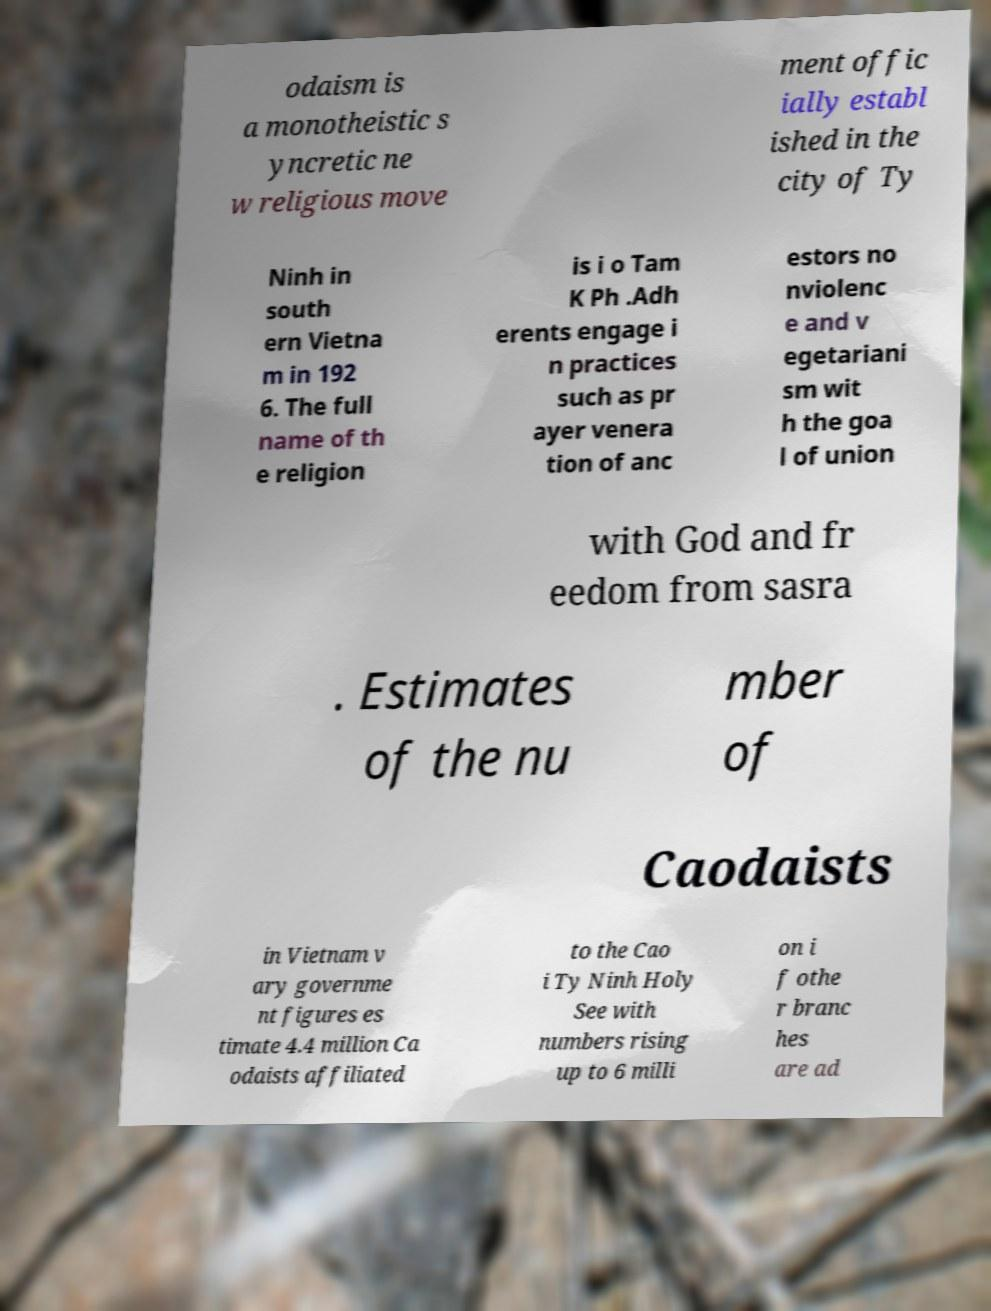I need the written content from this picture converted into text. Can you do that? odaism is a monotheistic s yncretic ne w religious move ment offic ially establ ished in the city of Ty Ninh in south ern Vietna m in 192 6. The full name of th e religion is i o Tam K Ph .Adh erents engage i n practices such as pr ayer venera tion of anc estors no nviolenc e and v egetariani sm wit h the goa l of union with God and fr eedom from sasra . Estimates of the nu mber of Caodaists in Vietnam v ary governme nt figures es timate 4.4 million Ca odaists affiliated to the Cao i Ty Ninh Holy See with numbers rising up to 6 milli on i f othe r branc hes are ad 